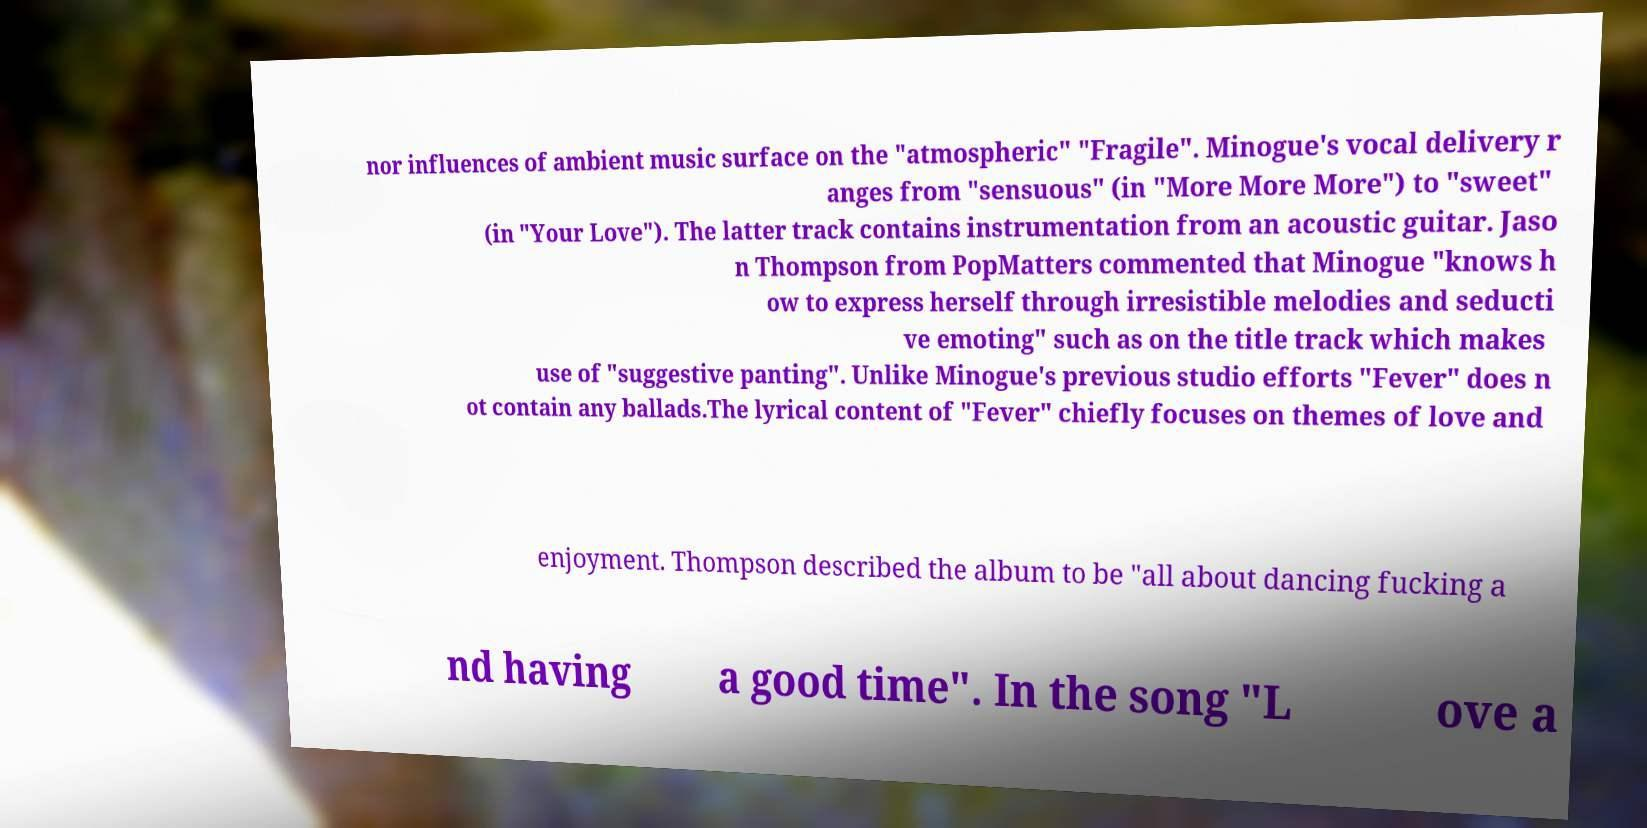Can you accurately transcribe the text from the provided image for me? nor influences of ambient music surface on the "atmospheric" "Fragile". Minogue's vocal delivery r anges from "sensuous" (in "More More More") to "sweet" (in "Your Love"). The latter track contains instrumentation from an acoustic guitar. Jaso n Thompson from PopMatters commented that Minogue "knows h ow to express herself through irresistible melodies and seducti ve emoting" such as on the title track which makes use of "suggestive panting". Unlike Minogue's previous studio efforts "Fever" does n ot contain any ballads.The lyrical content of "Fever" chiefly focuses on themes of love and enjoyment. Thompson described the album to be "all about dancing fucking a nd having a good time". In the song "L ove a 